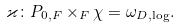Convert formula to latex. <formula><loc_0><loc_0><loc_500><loc_500>\varkappa \colon P _ { 0 , F } \times _ { F } \chi = \omega _ { D , \log } .</formula> 